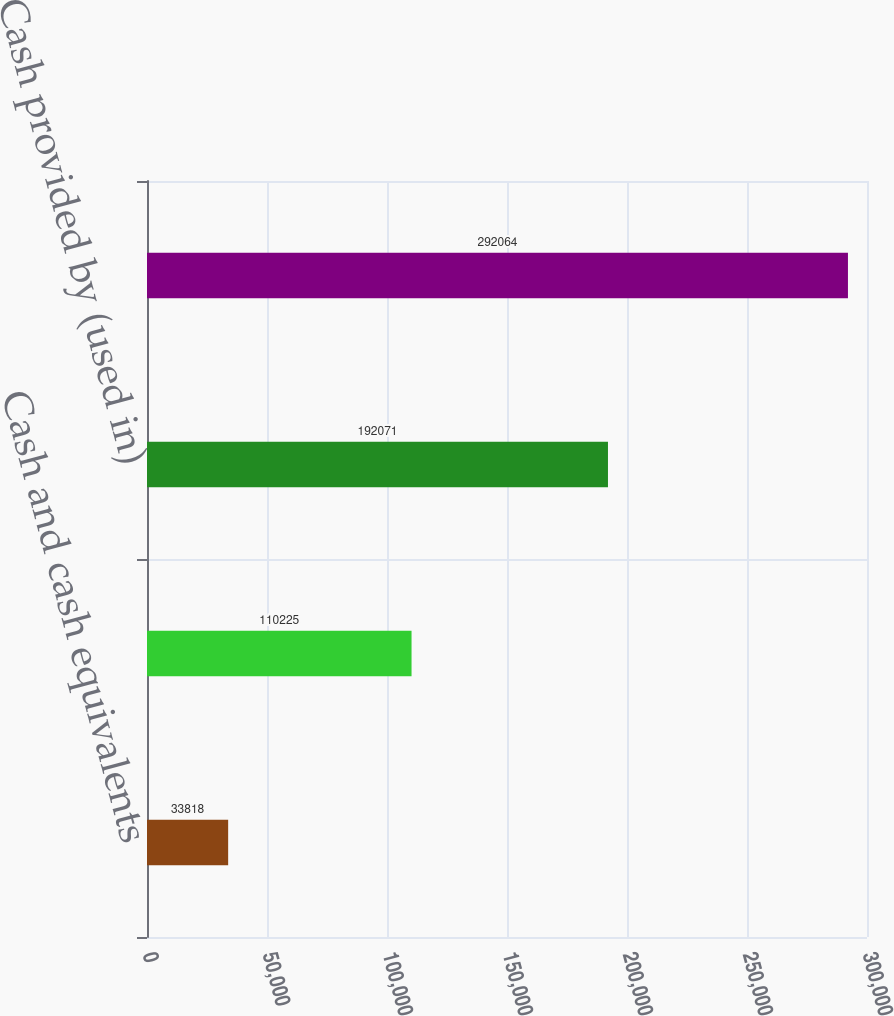Convert chart to OTSL. <chart><loc_0><loc_0><loc_500><loc_500><bar_chart><fcel>Cash and cash equivalents<fcel>Cash provided by operating<fcel>Cash provided by (used in)<fcel>Cash used in financing<nl><fcel>33818<fcel>110225<fcel>192071<fcel>292064<nl></chart> 